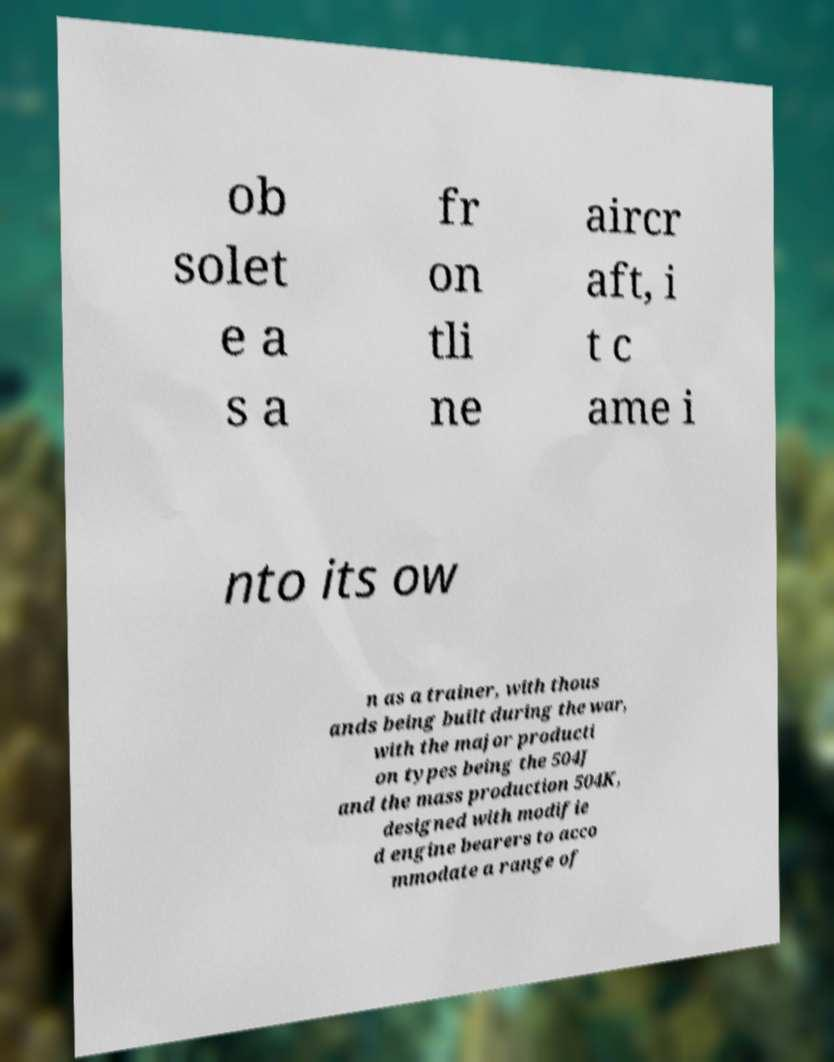Please read and relay the text visible in this image. What does it say? ob solet e a s a fr on tli ne aircr aft, i t c ame i nto its ow n as a trainer, with thous ands being built during the war, with the major producti on types being the 504J and the mass production 504K, designed with modifie d engine bearers to acco mmodate a range of 